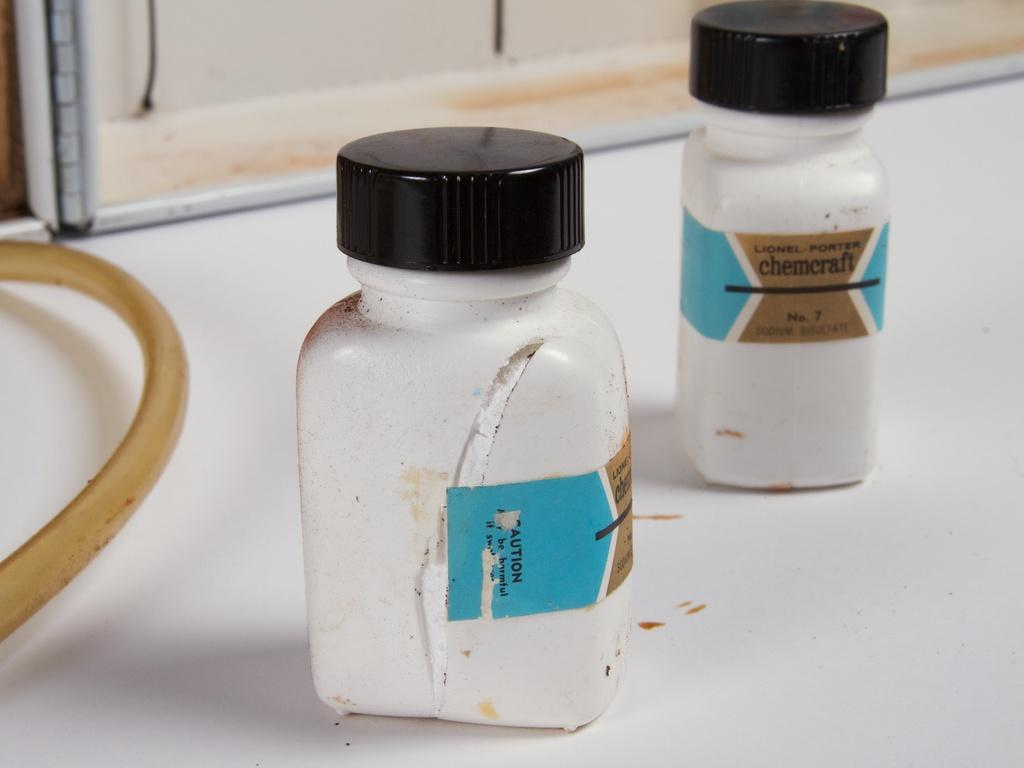<image>
Share a concise interpretation of the image provided. Two bottles, labelled Lionel-Porter chemcraft, are on a white surface. 